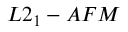Convert formula to latex. <formula><loc_0><loc_0><loc_500><loc_500>L 2 _ { 1 } - A F M</formula> 